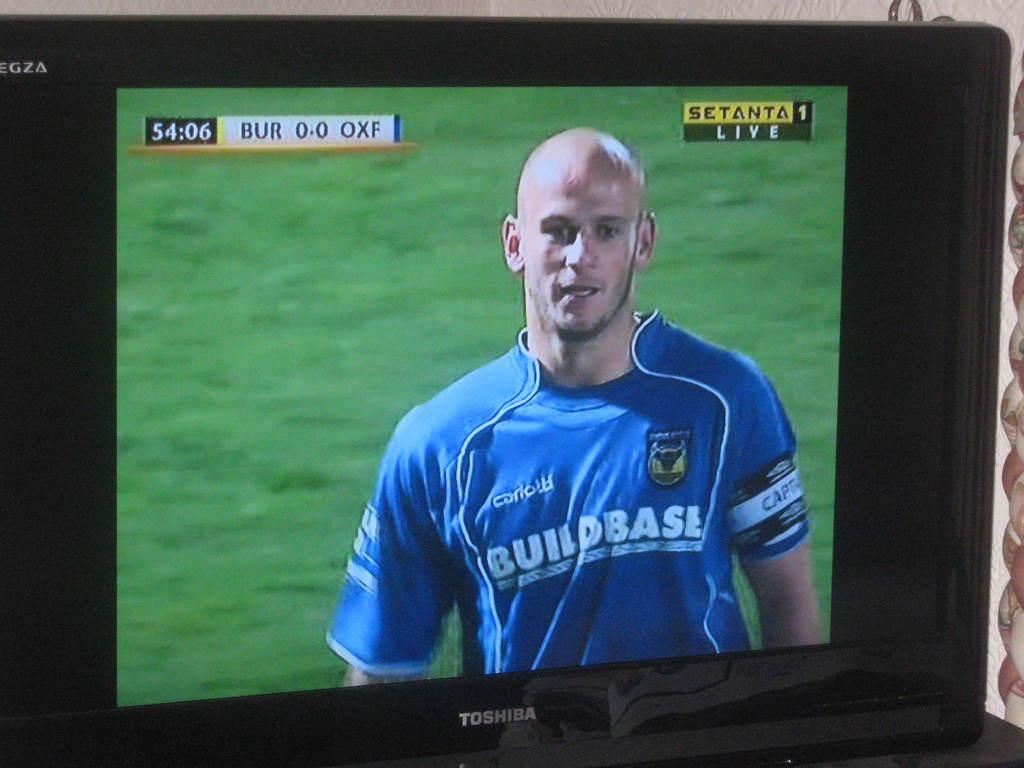<image>
Render a clear and concise summary of the photo. a toshiba flat screen tv showing sctanta live on the screen 